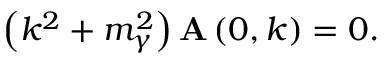Convert formula to latex. <formula><loc_0><loc_0><loc_500><loc_500>\left ( k ^ { 2 } + m _ { \gamma } ^ { 2 } \right ) { A } \left ( 0 , k \right ) = 0 .</formula> 